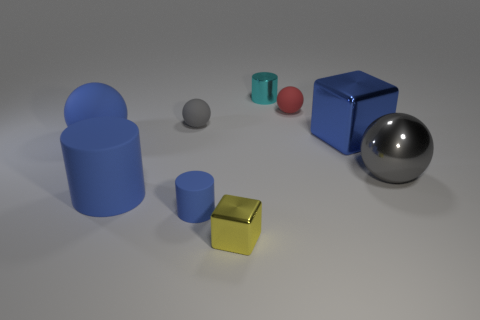How many gray spheres must be subtracted to get 1 gray spheres? 1 Subtract all brown cylinders. How many gray balls are left? 2 Subtract all blue spheres. How many spheres are left? 3 Subtract all big gray spheres. How many spheres are left? 3 Subtract all brown spheres. Subtract all purple blocks. How many spheres are left? 4 Subtract all spheres. How many objects are left? 5 Subtract 0 red cylinders. How many objects are left? 9 Subtract all red cubes. Subtract all shiny objects. How many objects are left? 5 Add 4 big matte balls. How many big matte balls are left? 5 Add 9 blue shiny objects. How many blue shiny objects exist? 10 